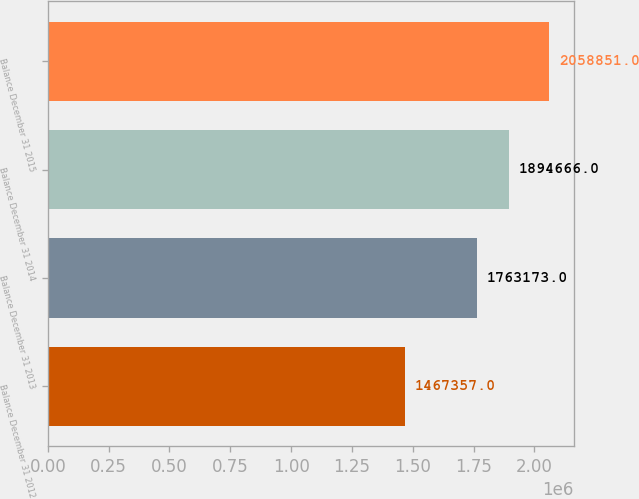Convert chart. <chart><loc_0><loc_0><loc_500><loc_500><bar_chart><fcel>Balance December 31 2012<fcel>Balance December 31 2013<fcel>Balance December 31 2014<fcel>Balance December 31 2015<nl><fcel>1.46736e+06<fcel>1.76317e+06<fcel>1.89467e+06<fcel>2.05885e+06<nl></chart> 